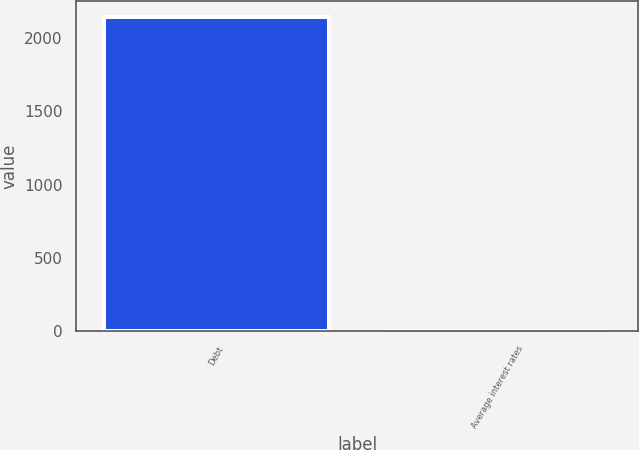<chart> <loc_0><loc_0><loc_500><loc_500><bar_chart><fcel>Debt<fcel>Average interest rates<nl><fcel>2146<fcel>5<nl></chart> 